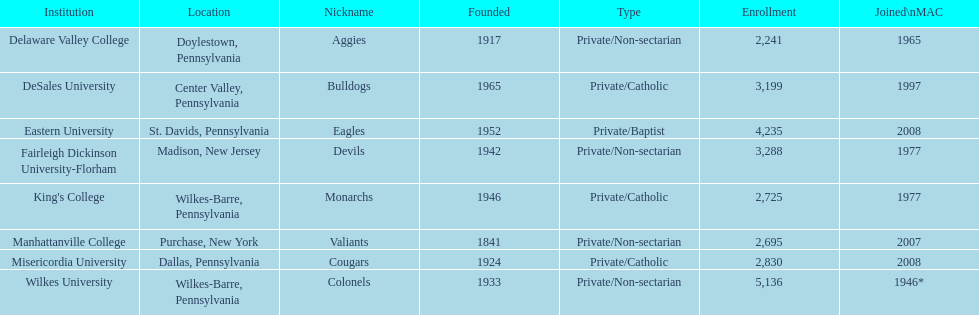What is the enrollment number of misericordia university? 2,830. 